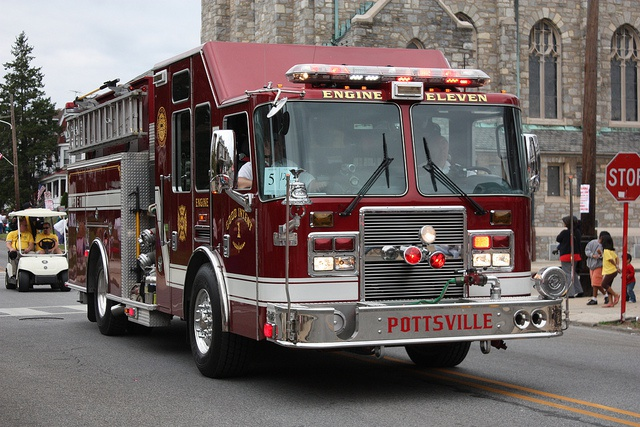Describe the objects in this image and their specific colors. I can see truck in lavender, black, gray, darkgray, and maroon tones, car in lavender, black, lightgray, gray, and darkgray tones, stop sign in lavender, maroon, darkgray, and brown tones, people in lavender, black, darkgray, and gray tones, and people in lavender, black, gray, brown, and maroon tones in this image. 